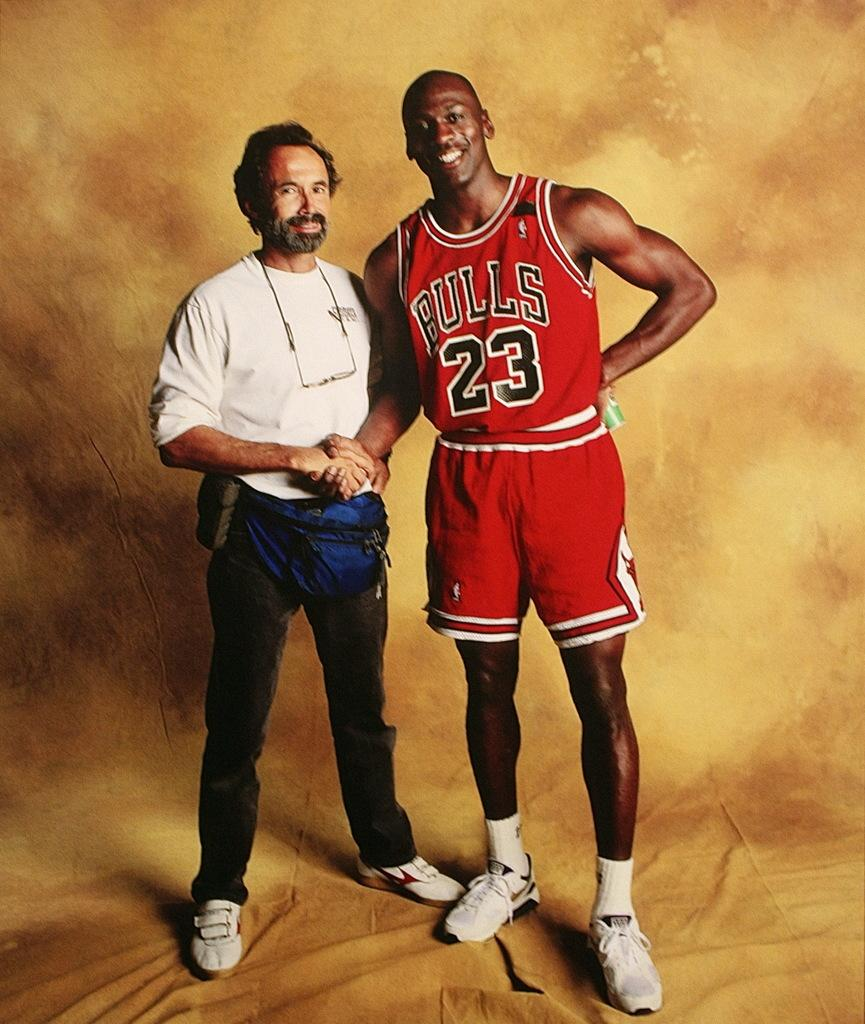<image>
Share a concise interpretation of the image provided. Michael Jordan poses for a picture shaking a mans hand. 